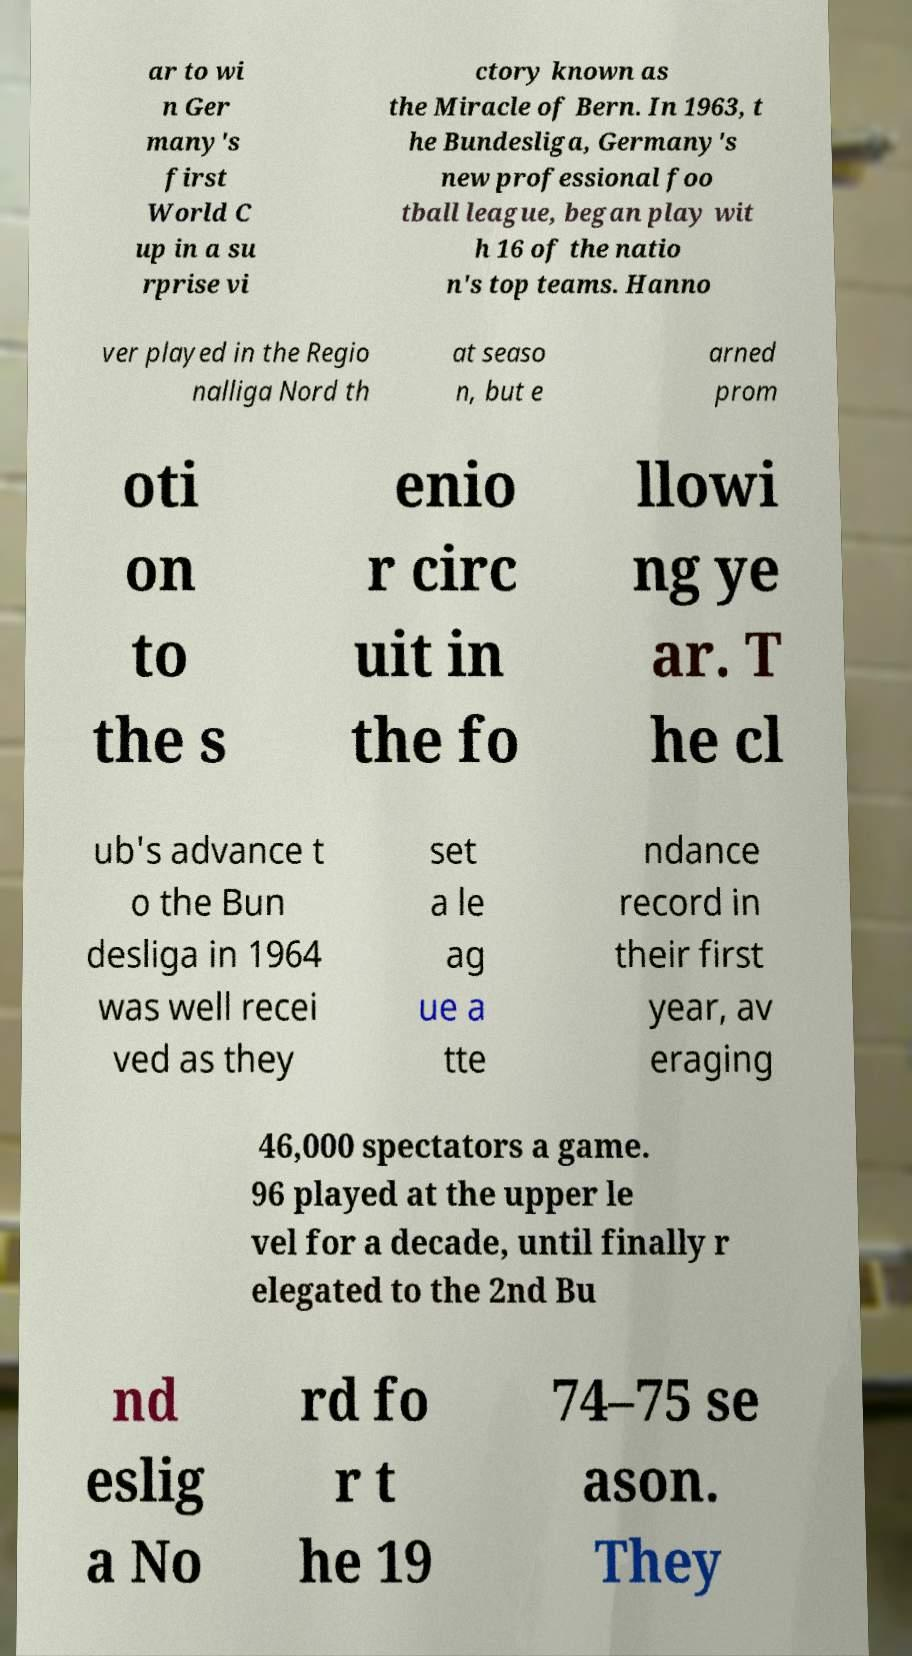Please read and relay the text visible in this image. What does it say? ar to wi n Ger many's first World C up in a su rprise vi ctory known as the Miracle of Bern. In 1963, t he Bundesliga, Germany's new professional foo tball league, began play wit h 16 of the natio n's top teams. Hanno ver played in the Regio nalliga Nord th at seaso n, but e arned prom oti on to the s enio r circ uit in the fo llowi ng ye ar. T he cl ub's advance t o the Bun desliga in 1964 was well recei ved as they set a le ag ue a tte ndance record in their first year, av eraging 46,000 spectators a game. 96 played at the upper le vel for a decade, until finally r elegated to the 2nd Bu nd eslig a No rd fo r t he 19 74–75 se ason. They 